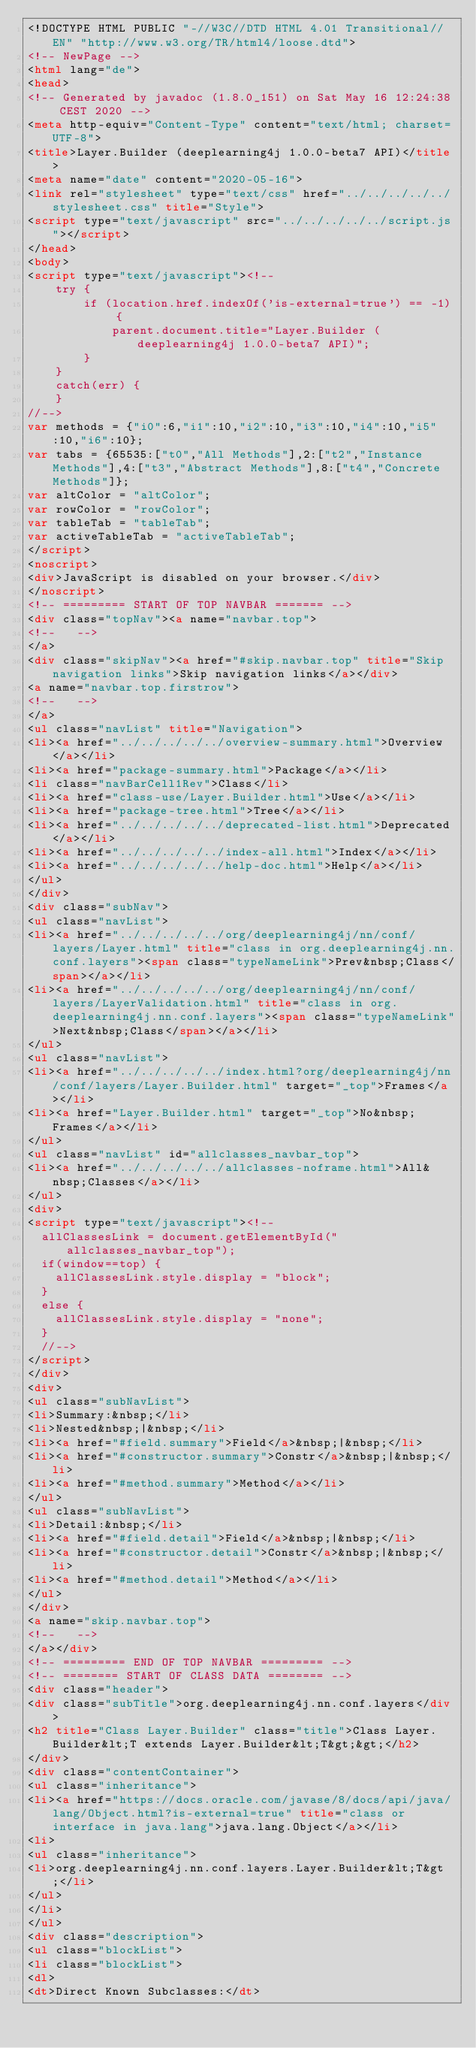<code> <loc_0><loc_0><loc_500><loc_500><_HTML_><!DOCTYPE HTML PUBLIC "-//W3C//DTD HTML 4.01 Transitional//EN" "http://www.w3.org/TR/html4/loose.dtd">
<!-- NewPage -->
<html lang="de">
<head>
<!-- Generated by javadoc (1.8.0_151) on Sat May 16 12:24:38 CEST 2020 -->
<meta http-equiv="Content-Type" content="text/html; charset=UTF-8">
<title>Layer.Builder (deeplearning4j 1.0.0-beta7 API)</title>
<meta name="date" content="2020-05-16">
<link rel="stylesheet" type="text/css" href="../../../../../stylesheet.css" title="Style">
<script type="text/javascript" src="../../../../../script.js"></script>
</head>
<body>
<script type="text/javascript"><!--
    try {
        if (location.href.indexOf('is-external=true') == -1) {
            parent.document.title="Layer.Builder (deeplearning4j 1.0.0-beta7 API)";
        }
    }
    catch(err) {
    }
//-->
var methods = {"i0":6,"i1":10,"i2":10,"i3":10,"i4":10,"i5":10,"i6":10};
var tabs = {65535:["t0","All Methods"],2:["t2","Instance Methods"],4:["t3","Abstract Methods"],8:["t4","Concrete Methods"]};
var altColor = "altColor";
var rowColor = "rowColor";
var tableTab = "tableTab";
var activeTableTab = "activeTableTab";
</script>
<noscript>
<div>JavaScript is disabled on your browser.</div>
</noscript>
<!-- ========= START OF TOP NAVBAR ======= -->
<div class="topNav"><a name="navbar.top">
<!--   -->
</a>
<div class="skipNav"><a href="#skip.navbar.top" title="Skip navigation links">Skip navigation links</a></div>
<a name="navbar.top.firstrow">
<!--   -->
</a>
<ul class="navList" title="Navigation">
<li><a href="../../../../../overview-summary.html">Overview</a></li>
<li><a href="package-summary.html">Package</a></li>
<li class="navBarCell1Rev">Class</li>
<li><a href="class-use/Layer.Builder.html">Use</a></li>
<li><a href="package-tree.html">Tree</a></li>
<li><a href="../../../../../deprecated-list.html">Deprecated</a></li>
<li><a href="../../../../../index-all.html">Index</a></li>
<li><a href="../../../../../help-doc.html">Help</a></li>
</ul>
</div>
<div class="subNav">
<ul class="navList">
<li><a href="../../../../../org/deeplearning4j/nn/conf/layers/Layer.html" title="class in org.deeplearning4j.nn.conf.layers"><span class="typeNameLink">Prev&nbsp;Class</span></a></li>
<li><a href="../../../../../org/deeplearning4j/nn/conf/layers/LayerValidation.html" title="class in org.deeplearning4j.nn.conf.layers"><span class="typeNameLink">Next&nbsp;Class</span></a></li>
</ul>
<ul class="navList">
<li><a href="../../../../../index.html?org/deeplearning4j/nn/conf/layers/Layer.Builder.html" target="_top">Frames</a></li>
<li><a href="Layer.Builder.html" target="_top">No&nbsp;Frames</a></li>
</ul>
<ul class="navList" id="allclasses_navbar_top">
<li><a href="../../../../../allclasses-noframe.html">All&nbsp;Classes</a></li>
</ul>
<div>
<script type="text/javascript"><!--
  allClassesLink = document.getElementById("allclasses_navbar_top");
  if(window==top) {
    allClassesLink.style.display = "block";
  }
  else {
    allClassesLink.style.display = "none";
  }
  //-->
</script>
</div>
<div>
<ul class="subNavList">
<li>Summary:&nbsp;</li>
<li>Nested&nbsp;|&nbsp;</li>
<li><a href="#field.summary">Field</a>&nbsp;|&nbsp;</li>
<li><a href="#constructor.summary">Constr</a>&nbsp;|&nbsp;</li>
<li><a href="#method.summary">Method</a></li>
</ul>
<ul class="subNavList">
<li>Detail:&nbsp;</li>
<li><a href="#field.detail">Field</a>&nbsp;|&nbsp;</li>
<li><a href="#constructor.detail">Constr</a>&nbsp;|&nbsp;</li>
<li><a href="#method.detail">Method</a></li>
</ul>
</div>
<a name="skip.navbar.top">
<!--   -->
</a></div>
<!-- ========= END OF TOP NAVBAR ========= -->
<!-- ======== START OF CLASS DATA ======== -->
<div class="header">
<div class="subTitle">org.deeplearning4j.nn.conf.layers</div>
<h2 title="Class Layer.Builder" class="title">Class Layer.Builder&lt;T extends Layer.Builder&lt;T&gt;&gt;</h2>
</div>
<div class="contentContainer">
<ul class="inheritance">
<li><a href="https://docs.oracle.com/javase/8/docs/api/java/lang/Object.html?is-external=true" title="class or interface in java.lang">java.lang.Object</a></li>
<li>
<ul class="inheritance">
<li>org.deeplearning4j.nn.conf.layers.Layer.Builder&lt;T&gt;</li>
</ul>
</li>
</ul>
<div class="description">
<ul class="blockList">
<li class="blockList">
<dl>
<dt>Direct Known Subclasses:</dt></code> 